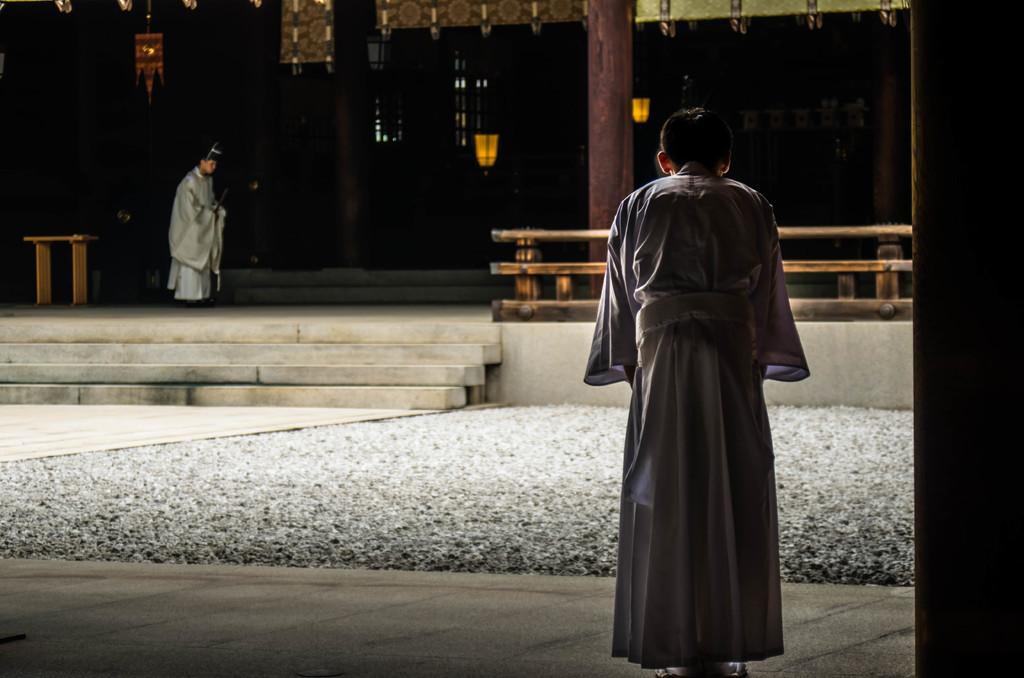In one or two sentences, can you explain what this image depicts? This image is taken outdoors. At the bottom of the image there is a floor. On the right side of the image there is a pillar. In the background there is a wall. There is a pillar. There is a railing. There are a few lights. A man is standing on the floor and there are a few stairs. On the left side of the image there is a table on the floor. In the middle of the image a man is standing on the floor and there are a few pebbles on the ground. 